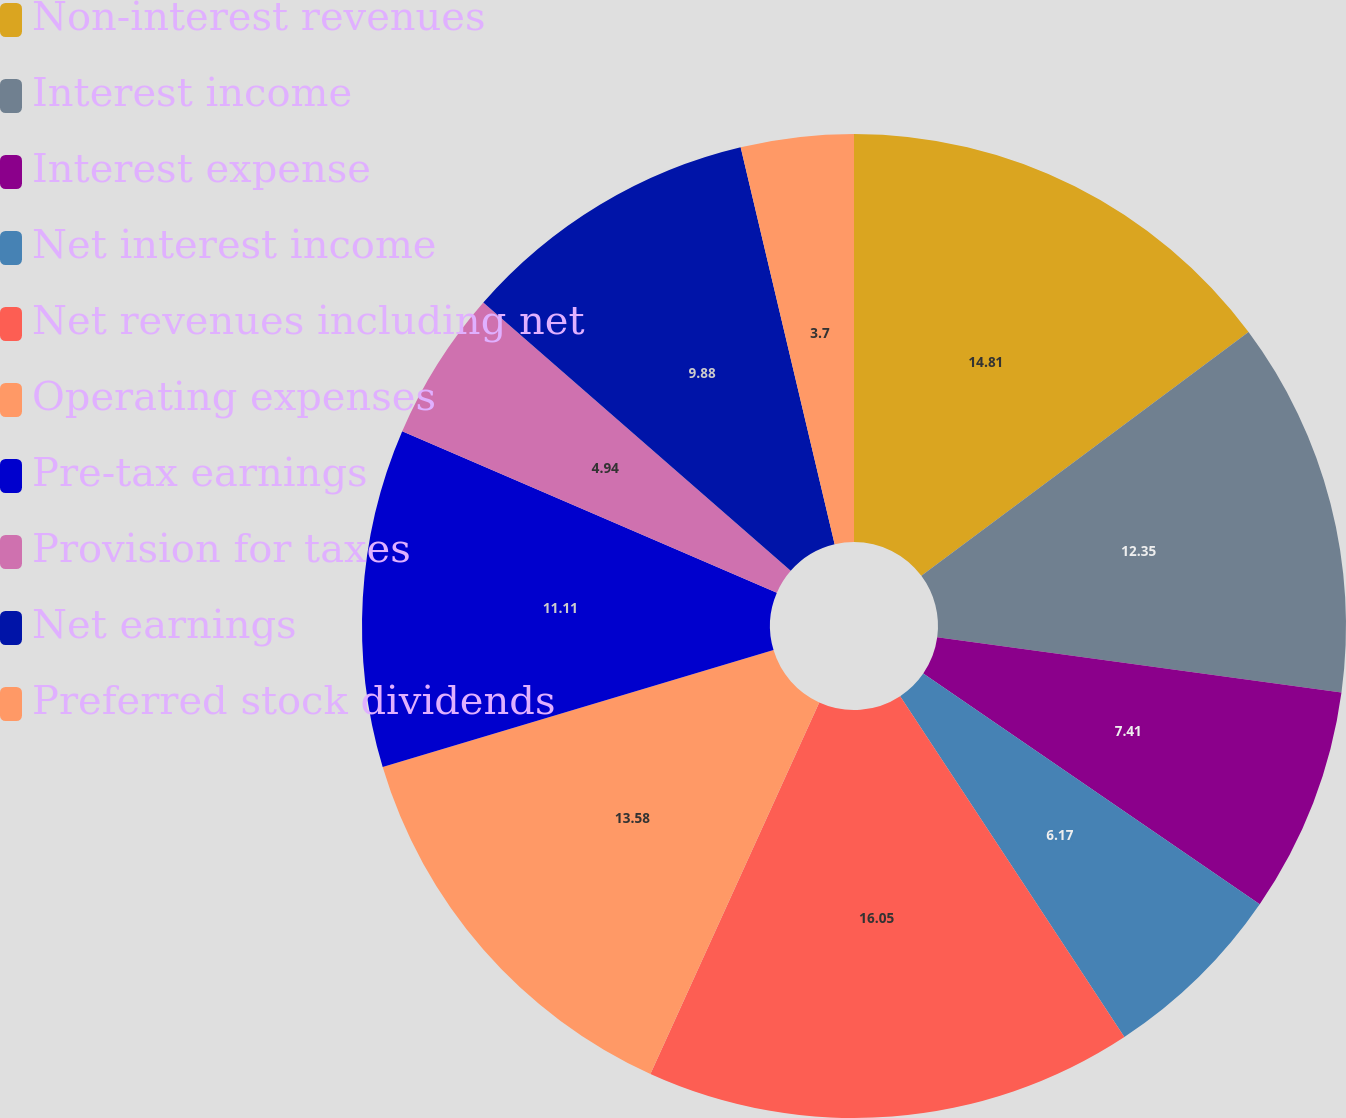<chart> <loc_0><loc_0><loc_500><loc_500><pie_chart><fcel>Non-interest revenues<fcel>Interest income<fcel>Interest expense<fcel>Net interest income<fcel>Net revenues including net<fcel>Operating expenses<fcel>Pre-tax earnings<fcel>Provision for taxes<fcel>Net earnings<fcel>Preferred stock dividends<nl><fcel>14.81%<fcel>12.35%<fcel>7.41%<fcel>6.17%<fcel>16.05%<fcel>13.58%<fcel>11.11%<fcel>4.94%<fcel>9.88%<fcel>3.7%<nl></chart> 